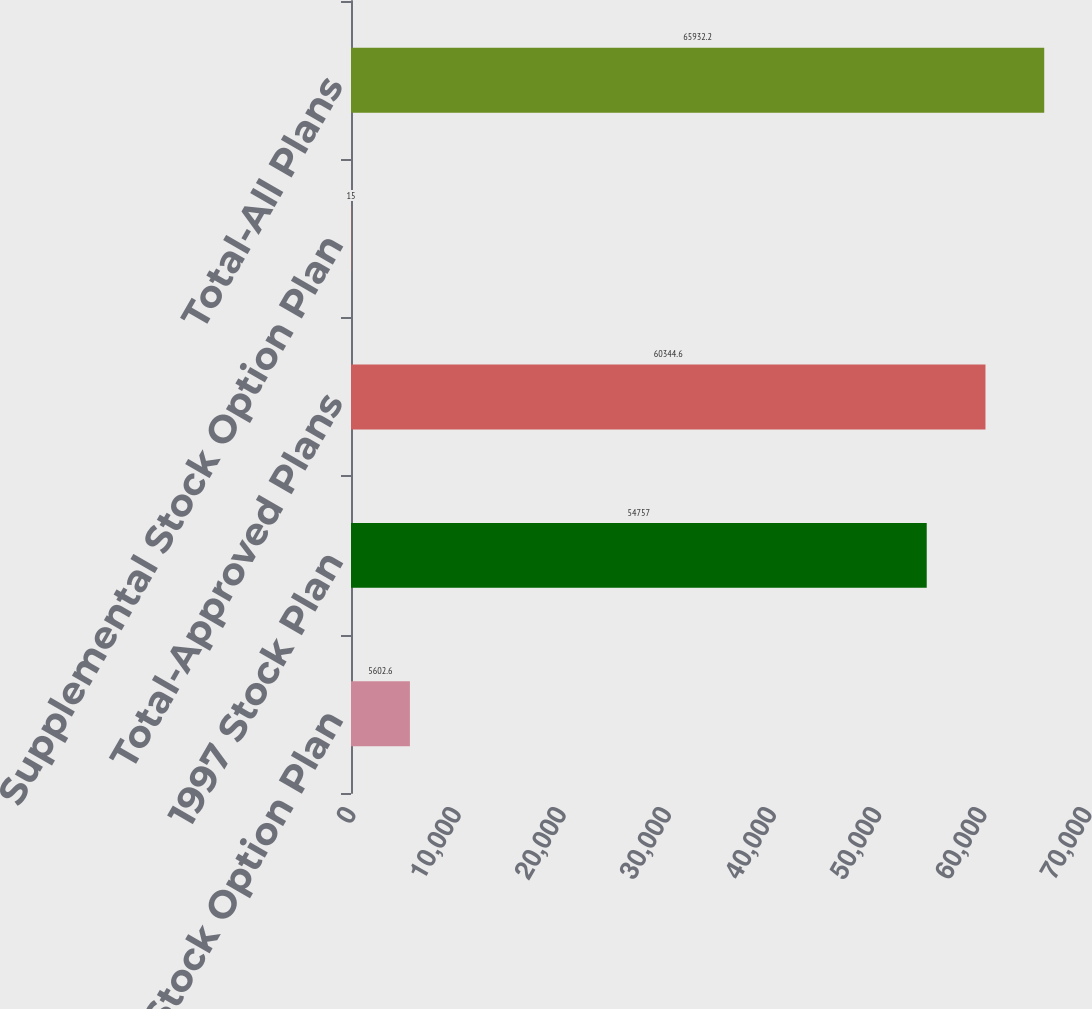Convert chart to OTSL. <chart><loc_0><loc_0><loc_500><loc_500><bar_chart><fcel>1988 Stock Option Plan<fcel>1997 Stock Plan<fcel>Total-Approved Plans<fcel>Supplemental Stock Option Plan<fcel>Total-All Plans<nl><fcel>5602.6<fcel>54757<fcel>60344.6<fcel>15<fcel>65932.2<nl></chart> 